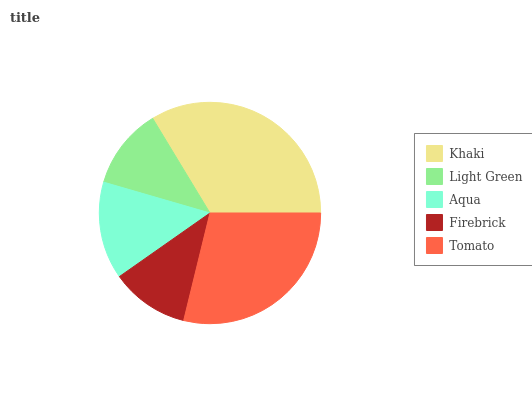Is Firebrick the minimum?
Answer yes or no. Yes. Is Khaki the maximum?
Answer yes or no. Yes. Is Light Green the minimum?
Answer yes or no. No. Is Light Green the maximum?
Answer yes or no. No. Is Khaki greater than Light Green?
Answer yes or no. Yes. Is Light Green less than Khaki?
Answer yes or no. Yes. Is Light Green greater than Khaki?
Answer yes or no. No. Is Khaki less than Light Green?
Answer yes or no. No. Is Aqua the high median?
Answer yes or no. Yes. Is Aqua the low median?
Answer yes or no. Yes. Is Khaki the high median?
Answer yes or no. No. Is Khaki the low median?
Answer yes or no. No. 